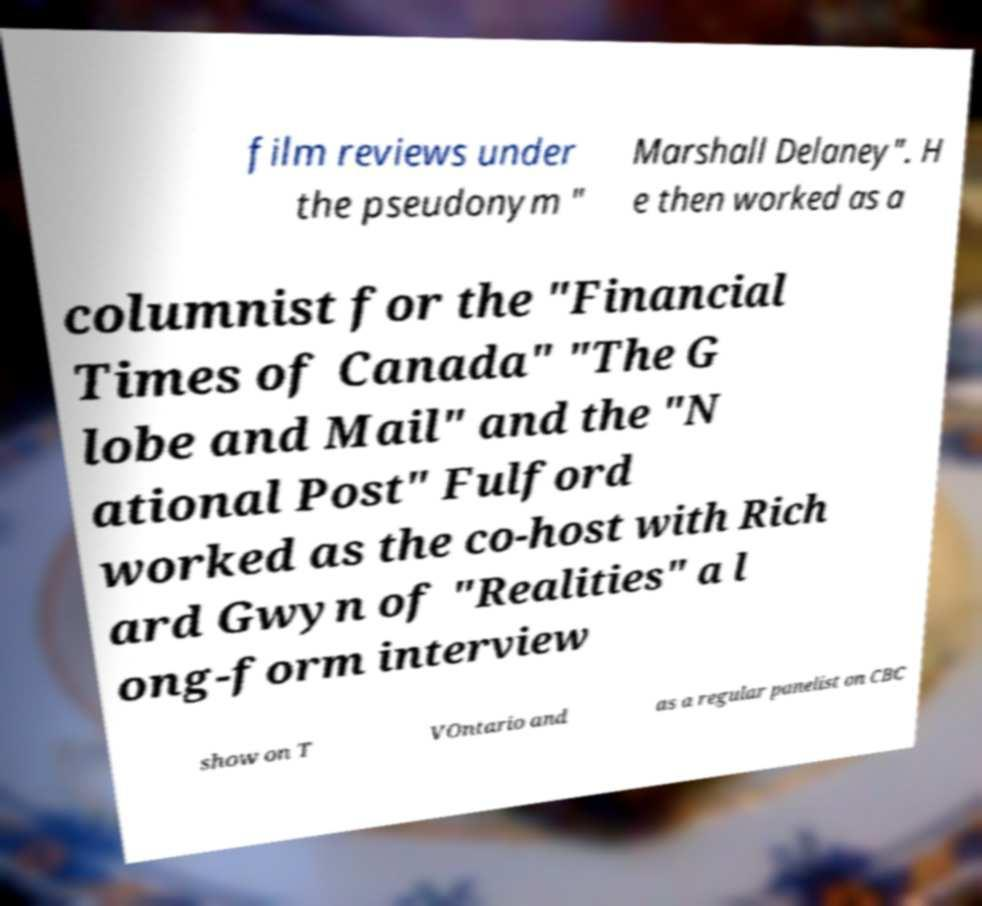Could you assist in decoding the text presented in this image and type it out clearly? film reviews under the pseudonym " Marshall Delaney". H e then worked as a columnist for the "Financial Times of Canada" "The G lobe and Mail" and the "N ational Post" Fulford worked as the co-host with Rich ard Gwyn of "Realities" a l ong-form interview show on T VOntario and as a regular panelist on CBC 